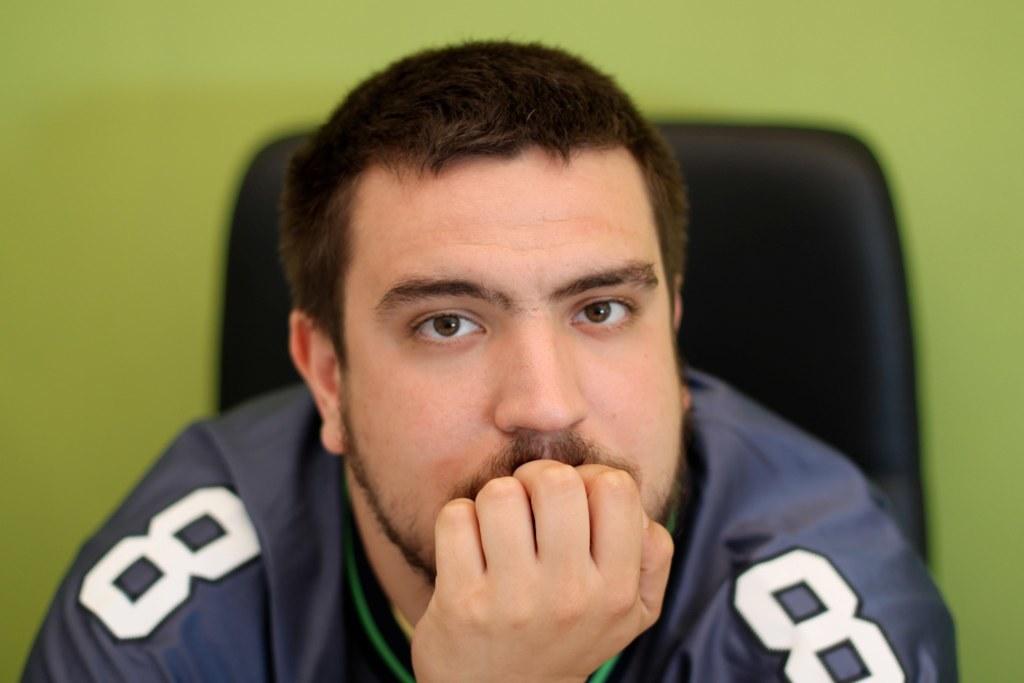What number is on the jersey?
Provide a succinct answer. 8. 